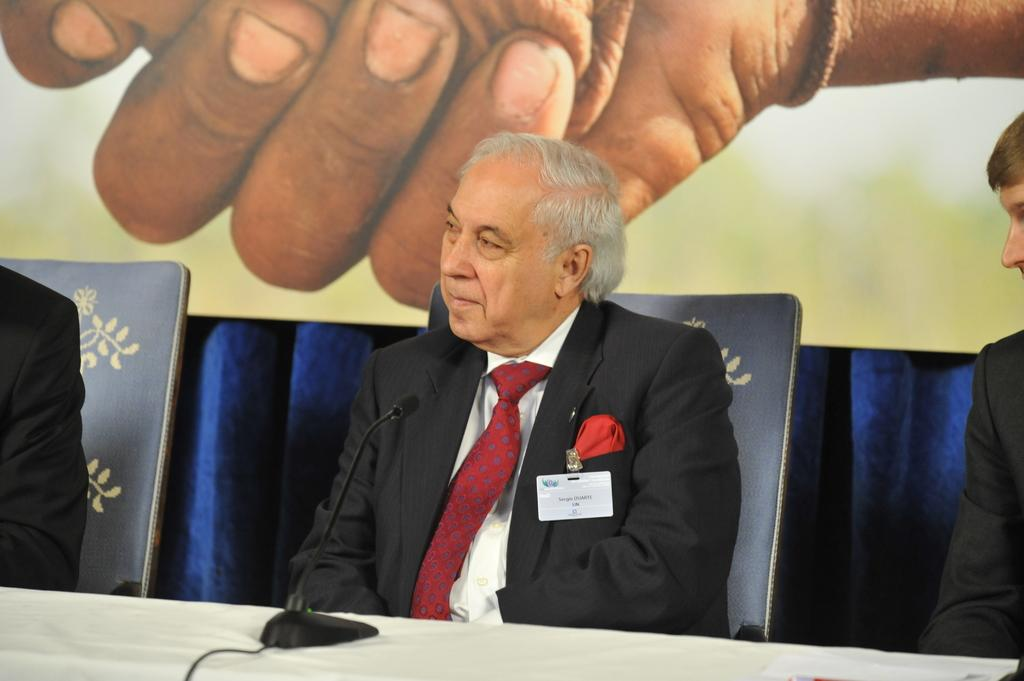What is located in the foreground of the picture? There are people, chairs, a table, a cable, and an electronic gadget in the foreground of the picture. What can be seen in the background of the picture? There is a banner and a curtain in the background of the picture. How many people are visible in the foreground of the picture? The number of people visible in the foreground of the picture is not specified, but there are people present. What type of electronic gadget is in the foreground of the picture? The specific type of electronic gadget is not mentioned, but there is an electronic gadget present in the foreground of the picture. What type of engine is visible in the picture? There is no engine present in the picture. Can you tell me how many buttons are on the electronic gadget in the picture? The number of buttons on the electronic gadget in the picture is not specified, but there is an electronic gadget present. 